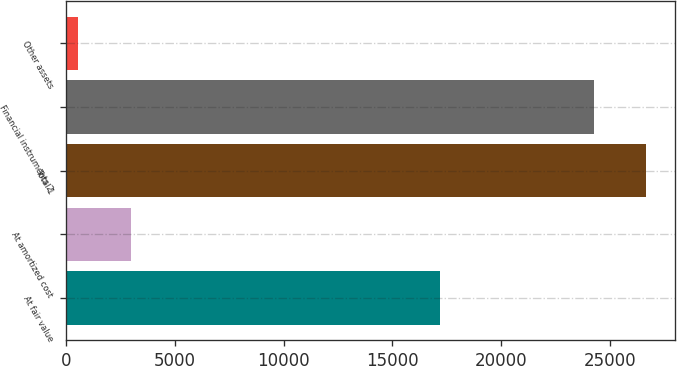<chart> <loc_0><loc_0><loc_500><loc_500><bar_chart><fcel>At fair value<fcel>At amortized cost<fcel>Total 1<fcel>Financial instruments 2<fcel>Other assets<nl><fcel>17202<fcel>2992.6<fcel>26670.6<fcel>24246<fcel>568<nl></chart> 